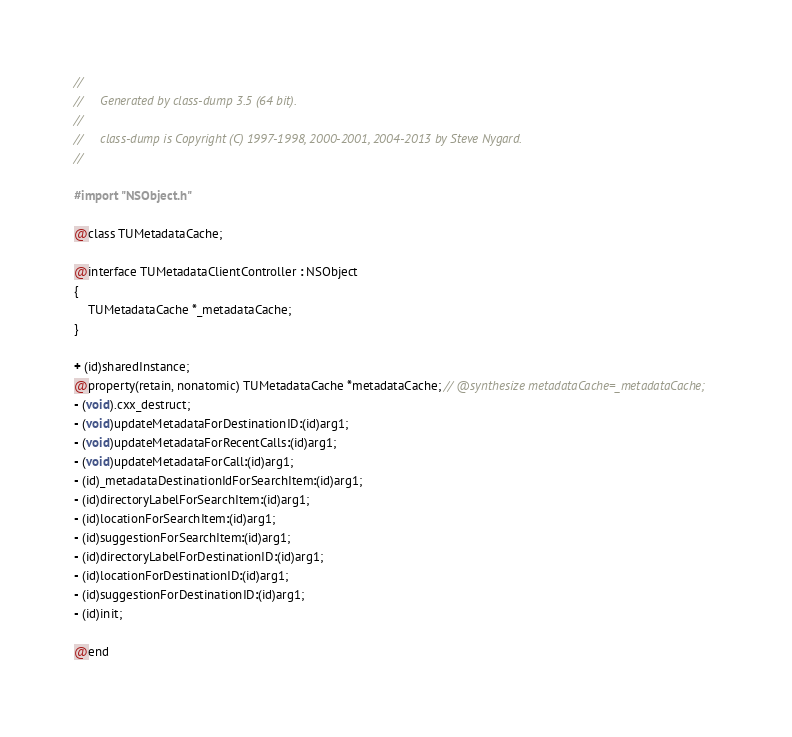<code> <loc_0><loc_0><loc_500><loc_500><_C_>//
//     Generated by class-dump 3.5 (64 bit).
//
//     class-dump is Copyright (C) 1997-1998, 2000-2001, 2004-2013 by Steve Nygard.
//

#import "NSObject.h"

@class TUMetadataCache;

@interface TUMetadataClientController : NSObject
{
    TUMetadataCache *_metadataCache;
}

+ (id)sharedInstance;
@property(retain, nonatomic) TUMetadataCache *metadataCache; // @synthesize metadataCache=_metadataCache;
- (void).cxx_destruct;
- (void)updateMetadataForDestinationID:(id)arg1;
- (void)updateMetadataForRecentCalls:(id)arg1;
- (void)updateMetadataForCall:(id)arg1;
- (id)_metadataDestinationIdForSearchItem:(id)arg1;
- (id)directoryLabelForSearchItem:(id)arg1;
- (id)locationForSearchItem:(id)arg1;
- (id)suggestionForSearchItem:(id)arg1;
- (id)directoryLabelForDestinationID:(id)arg1;
- (id)locationForDestinationID:(id)arg1;
- (id)suggestionForDestinationID:(id)arg1;
- (id)init;

@end

</code> 